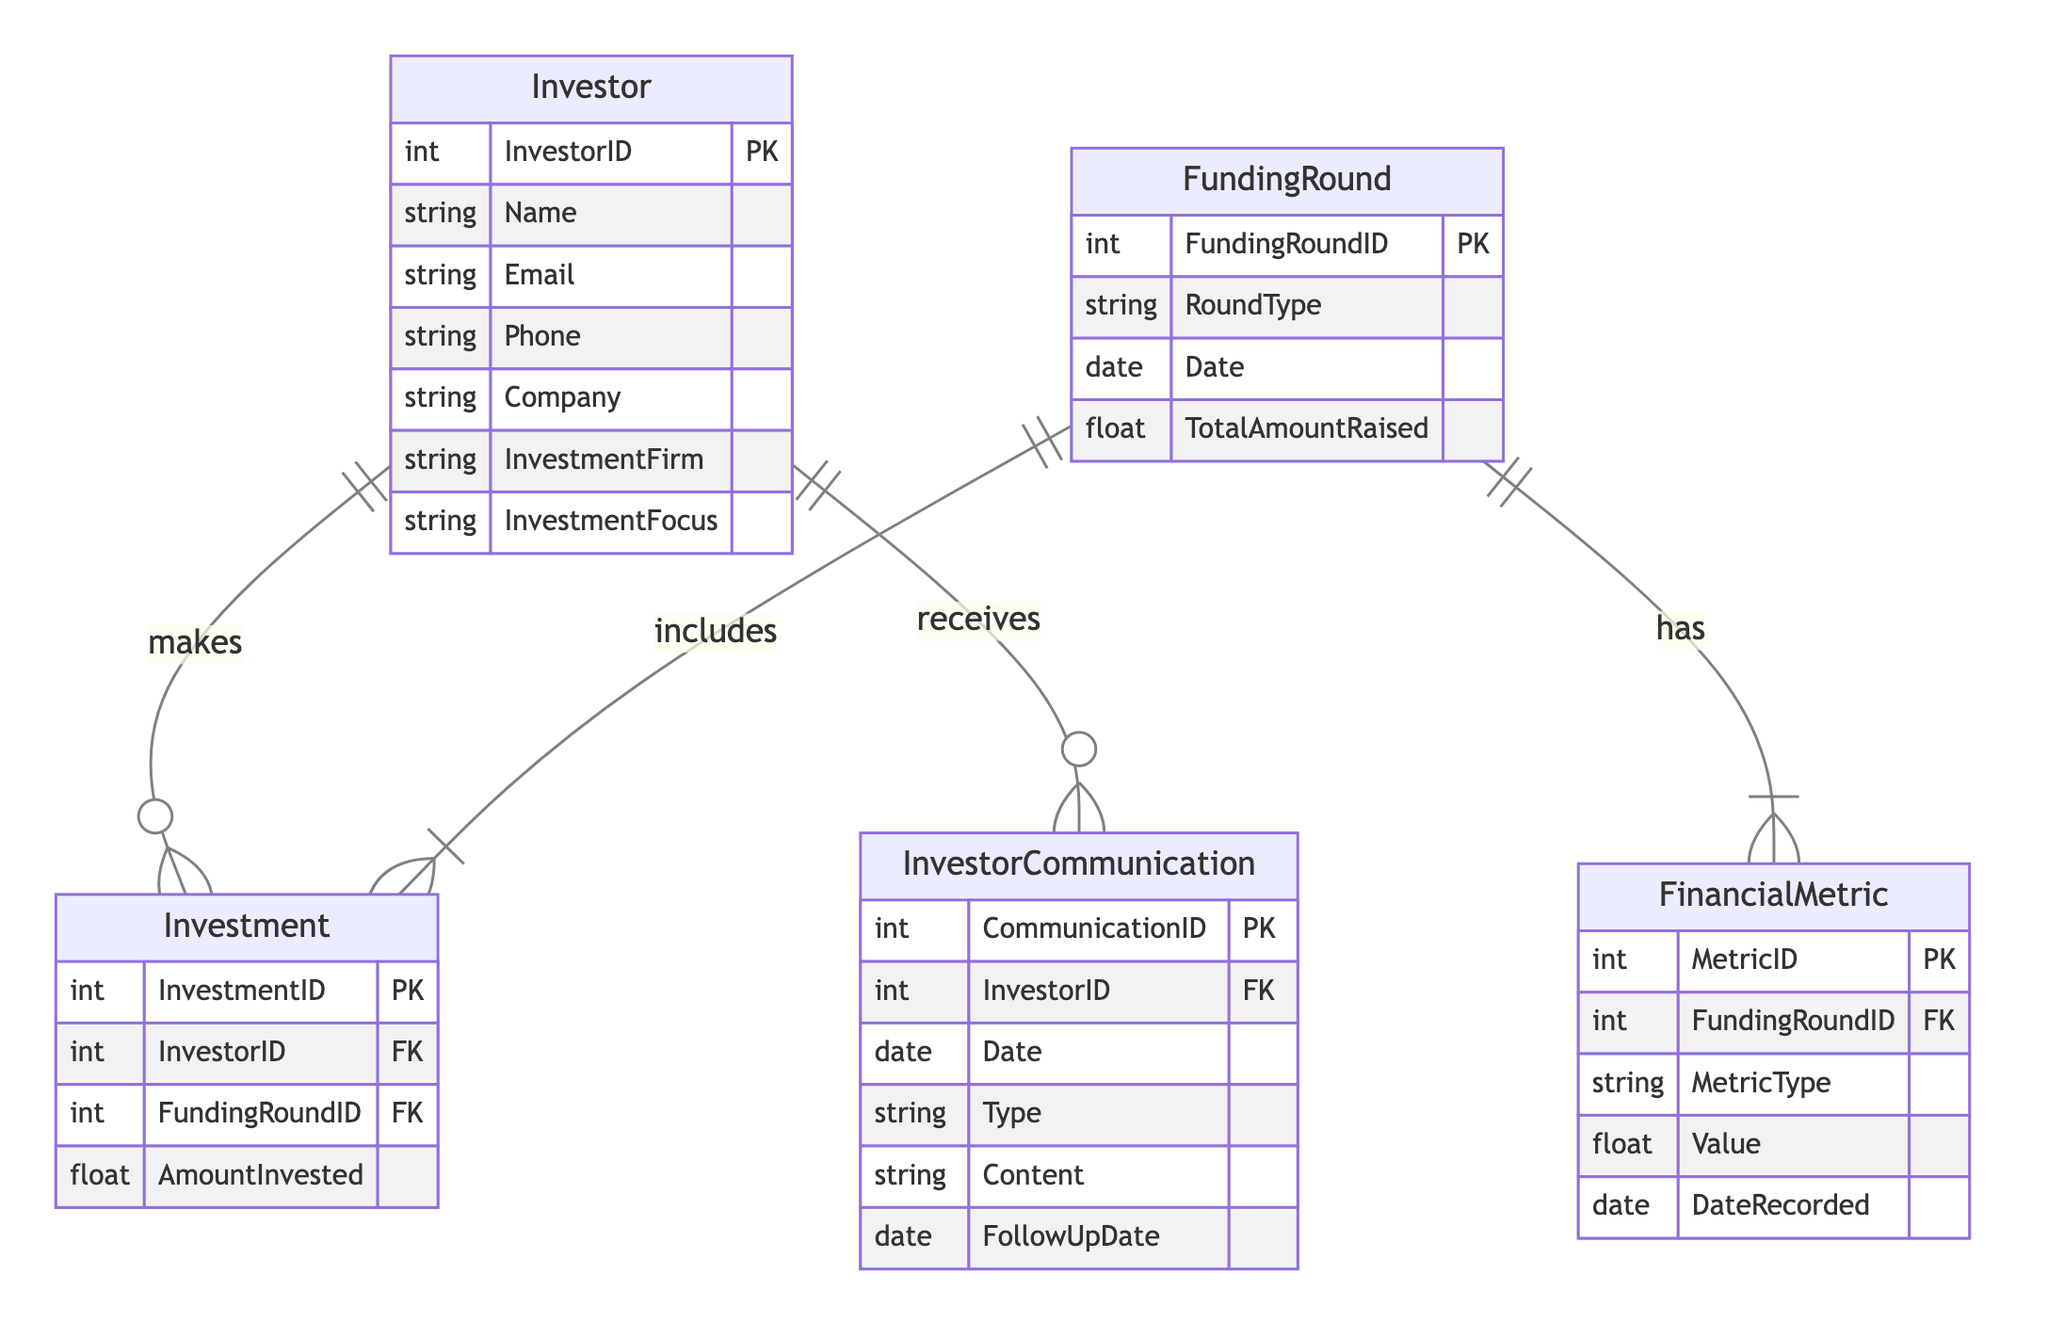What is the primary key of the Investor entity? The primary key of the Investor entity is InvestorID, which uniquely identifies each investor in the diagram.
Answer: InvestorID How many entities are present in the diagram? There are five entities in the diagram: Investor, FundingRound, Investment, FinancialMetric, and InvestorCommunication.
Answer: Five What relationship connects Investor and FundingRound? The relationship connecting Investor and FundingRound is called "InvestsIn," indicating that an investor can invest in various funding rounds, and that additional data (like AmountInvested) is associated with this relationship.
Answer: InvestsIn What type of relationship exists between FundingRound and FinancialMetric? The relationship between FundingRound and FinancialMetric is a "HasMetric" relationship, illustrating that each funding round can have multiple associated financial metrics.
Answer: HasMetric How many attributes does the InvestorCommunication entity have? The InvestorCommunication entity has six attributes: CommunicationID, InvestorID, Date, Type, Content, and FollowUpDate.
Answer: Six Which entity has an attribute named TotalAmountRaised? The FundingRound entity includes an attribute named TotalAmountRaised, representing the total amount collected during that particular funding round.
Answer: FundingRound What is the foreign key in the Investment entity that links to the Investor entity? The foreign key in the Investment entity linking to the Investor entity is InvestorID, which connects each investment to a specific investor.
Answer: InvestorID Which entity's attributes include Date and Type? The InvestorCommunication entity includes the attributes Date and Type, capturing the communication date and the nature of the communication, respectively.
Answer: InvestorCommunication How many relationships are defined in the diagram? There are three relationships defined in the diagram: InvestsIn, HasMetric, and CommunicatesWith, each illustrating different connections between entities.
Answer: Three What does the AmountInvested attribute signify in the Investment relationship? The AmountInvested attribute signifies the amount of money that an investor has committed to a particular funding round, indicating the investor's financial contribution.
Answer: AmountInvested 